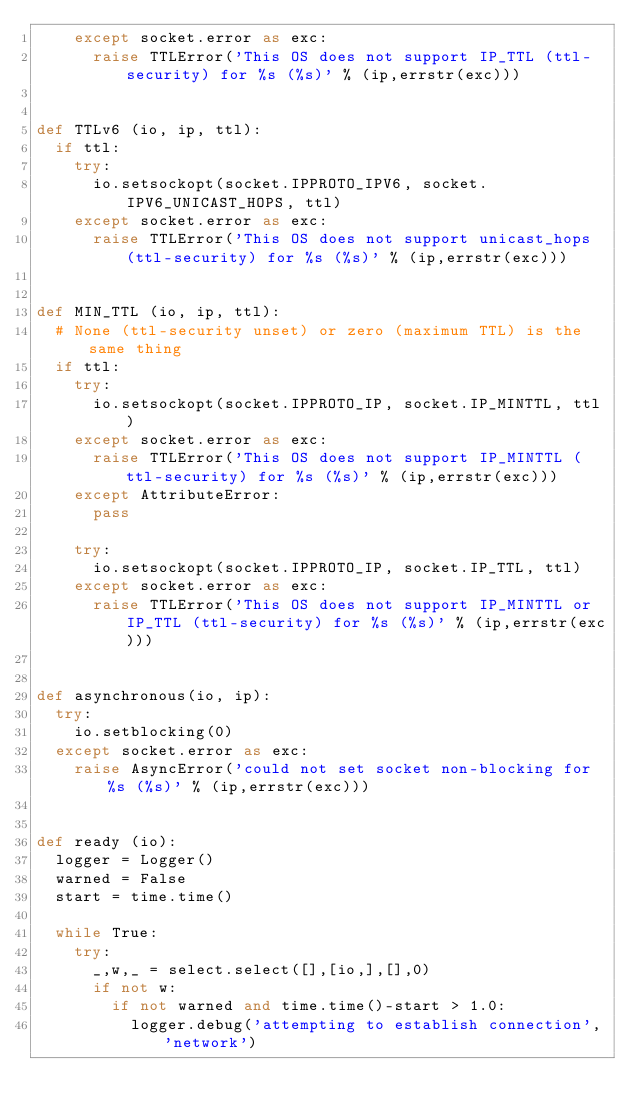Convert code to text. <code><loc_0><loc_0><loc_500><loc_500><_Python_>		except socket.error as exc:
			raise TTLError('This OS does not support IP_TTL (ttl-security) for %s (%s)' % (ip,errstr(exc)))


def TTLv6 (io, ip, ttl):
	if ttl:
		try:
			io.setsockopt(socket.IPPROTO_IPV6, socket.IPV6_UNICAST_HOPS, ttl)
		except socket.error as exc:
			raise TTLError('This OS does not support unicast_hops (ttl-security) for %s (%s)' % (ip,errstr(exc)))


def MIN_TTL (io, ip, ttl):
	# None (ttl-security unset) or zero (maximum TTL) is the same thing
	if ttl:
		try:
			io.setsockopt(socket.IPPROTO_IP, socket.IP_MINTTL, ttl)
		except socket.error as exc:
			raise TTLError('This OS does not support IP_MINTTL (ttl-security) for %s (%s)' % (ip,errstr(exc)))
		except AttributeError:
			pass

		try:
			io.setsockopt(socket.IPPROTO_IP, socket.IP_TTL, ttl)
		except socket.error as exc:
			raise TTLError('This OS does not support IP_MINTTL or IP_TTL (ttl-security) for %s (%s)' % (ip,errstr(exc)))


def asynchronous(io, ip):
	try:
		io.setblocking(0)
	except socket.error as exc:
		raise AsyncError('could not set socket non-blocking for %s (%s)' % (ip,errstr(exc)))


def ready (io):
	logger = Logger()
	warned = False
	start = time.time()

	while True:
		try:
			_,w,_ = select.select([],[io,],[],0)
			if not w:
				if not warned and time.time()-start > 1.0:
					logger.debug('attempting to establish connection','network')</code> 